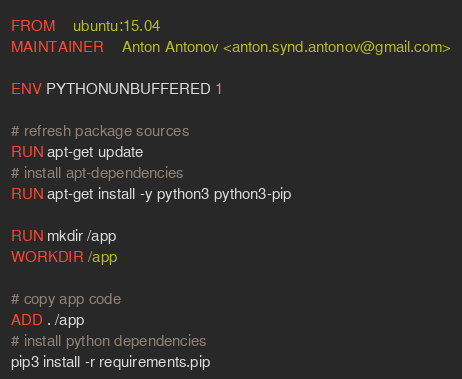<code> <loc_0><loc_0><loc_500><loc_500><_Dockerfile_>FROM	ubuntu:15.04
MAINTAINER	Anton Antonov <anton.synd.antonov@gmail.com>

ENV PYTHONUNBUFFERED 1

# refresh package sources
RUN apt-get update
# install apt-dependencies
RUN apt-get install -y python3 python3-pip

RUN mkdir /app
WORKDIR /app

# copy app code
ADD . /app
# install python dependencies
pip3 install -r requirements.pip
</code> 